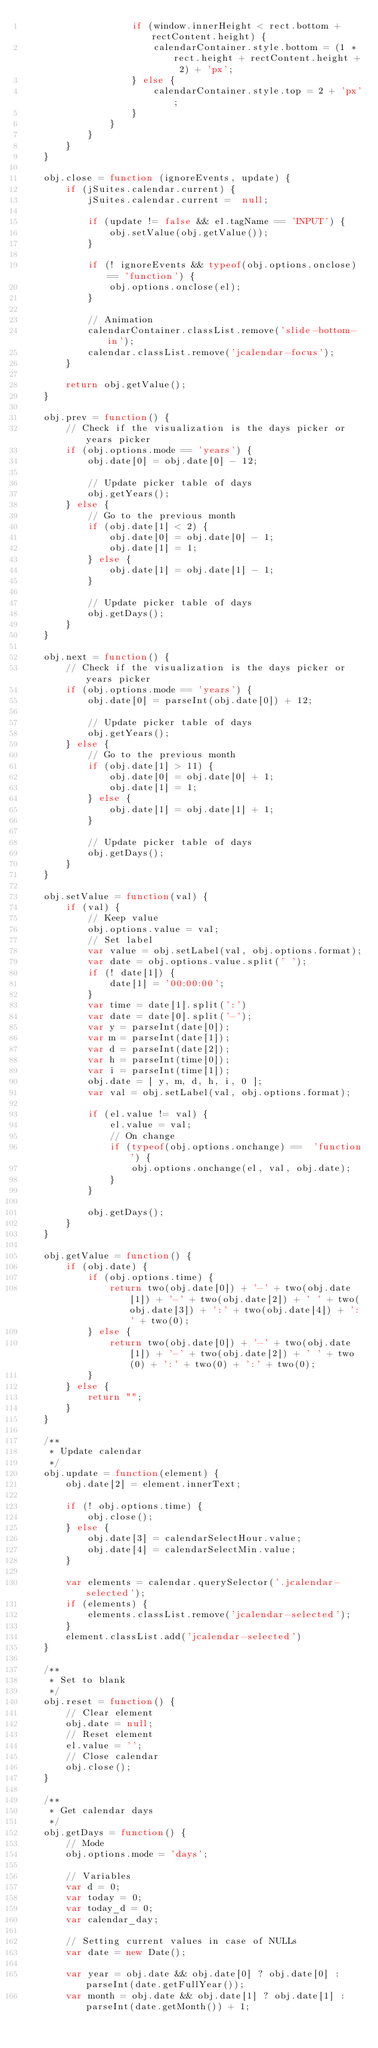Convert code to text. <code><loc_0><loc_0><loc_500><loc_500><_JavaScript_>                    if (window.innerHeight < rect.bottom + rectContent.height) {
                        calendarContainer.style.bottom = (1 * rect.height + rectContent.height + 2) + 'px';
                    } else {
                        calendarContainer.style.top = 2 + 'px'; 
                    }
                }
            }
        }
    }

    obj.close = function (ignoreEvents, update) {
        if (jSuites.calendar.current) {
            jSuites.calendar.current =  null;

            if (update != false && el.tagName == 'INPUT') {
                obj.setValue(obj.getValue());
            }

            if (! ignoreEvents && typeof(obj.options.onclose) == 'function') {
                obj.options.onclose(el);
            }

            // Animation
            calendarContainer.classList.remove('slide-bottom-in');
            calendar.classList.remove('jcalendar-focus');
        }

        return obj.getValue(); 
    }

    obj.prev = function() {
        // Check if the visualization is the days picker or years picker
        if (obj.options.mode == 'years') {
            obj.date[0] = obj.date[0] - 12;

            // Update picker table of days
            obj.getYears();
        } else {
            // Go to the previous month
            if (obj.date[1] < 2) {
                obj.date[0] = obj.date[0] - 1;
                obj.date[1] = 1;
            } else {
                obj.date[1] = obj.date[1] - 1;
            }

            // Update picker table of days
            obj.getDays();
        }
    }

    obj.next = function() {
        // Check if the visualization is the days picker or years picker
        if (obj.options.mode == 'years') {
            obj.date[0] = parseInt(obj.date[0]) + 12;

            // Update picker table of days
            obj.getYears();
        } else {
            // Go to the previous month
            if (obj.date[1] > 11) {
                obj.date[0] = obj.date[0] + 1;
                obj.date[1] = 1;
            } else {
                obj.date[1] = obj.date[1] + 1;
            }

            // Update picker table of days
            obj.getDays();
        }
    }

    obj.setValue = function(val) {
        if (val) {
            // Keep value
            obj.options.value = val;
            // Set label
            var value = obj.setLabel(val, obj.options.format);
            var date = obj.options.value.split(' ');
            if (! date[1]) {
                date[1] = '00:00:00';
            }
            var time = date[1].split(':')
            var date = date[0].split('-');
            var y = parseInt(date[0]);
            var m = parseInt(date[1]);
            var d = parseInt(date[2]);
            var h = parseInt(time[0]);
            var i = parseInt(time[1]);
            obj.date = [ y, m, d, h, i, 0 ];
            var val = obj.setLabel(val, obj.options.format);

            if (el.value != val) {
                el.value = val;
                // On change
                if (typeof(obj.options.onchange) ==  'function') {
                    obj.options.onchange(el, val, obj.date);
                }
            }

            obj.getDays();
        }
    }

    obj.getValue = function() {
        if (obj.date) {
            if (obj.options.time) {
                return two(obj.date[0]) + '-' + two(obj.date[1]) + '-' + two(obj.date[2]) + ' ' + two(obj.date[3]) + ':' + two(obj.date[4]) + ':' + two(0);
            } else {
                return two(obj.date[0]) + '-' + two(obj.date[1]) + '-' + two(obj.date[2]) + ' ' + two(0) + ':' + two(0) + ':' + two(0);
            }
        } else {
            return "";
        }
    }

    /**
     * Update calendar
     */
    obj.update = function(element) {
        obj.date[2] = element.innerText;

        if (! obj.options.time) {
            obj.close();
        } else {
            obj.date[3] = calendarSelectHour.value;
            obj.date[4] = calendarSelectMin.value;
        }

        var elements = calendar.querySelector('.jcalendar-selected');
        if (elements) {
            elements.classList.remove('jcalendar-selected');
        }
        element.classList.add('jcalendar-selected')
    }

    /**
     * Set to blank
     */
    obj.reset = function() {
        // Clear element
        obj.date = null;
        // Reset element
        el.value = '';
        // Close calendar
        obj.close();
    }

    /**
     * Get calendar days
     */
    obj.getDays = function() {
        // Mode
        obj.options.mode = 'days';

        // Variables
        var d = 0;
        var today = 0;
        var today_d = 0;
        var calendar_day;

        // Setting current values in case of NULLs
        var date = new Date();

        var year = obj.date && obj.date[0] ? obj.date[0] : parseInt(date.getFullYear());
        var month = obj.date && obj.date[1] ? obj.date[1] : parseInt(date.getMonth()) + 1;</code> 